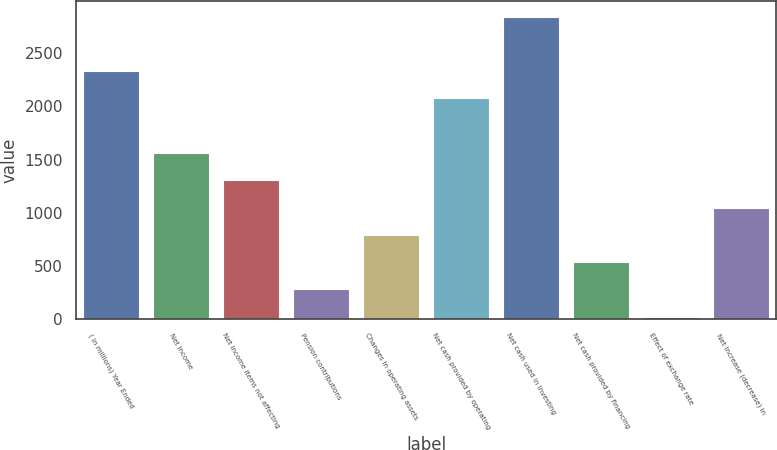<chart> <loc_0><loc_0><loc_500><loc_500><bar_chart><fcel>( in millions) Year Ended<fcel>Net income<fcel>Net income items not affecting<fcel>Pension contributions<fcel>Changes in operating assets<fcel>Net cash provided by operating<fcel>Net cash used in investing<fcel>Net cash provided by financing<fcel>Effect of exchange rate<fcel>Net increase (decrease) in<nl><fcel>2331.72<fcel>1562.88<fcel>1306.6<fcel>281.48<fcel>794.04<fcel>2075.44<fcel>2844.28<fcel>537.76<fcel>25.2<fcel>1050.32<nl></chart> 